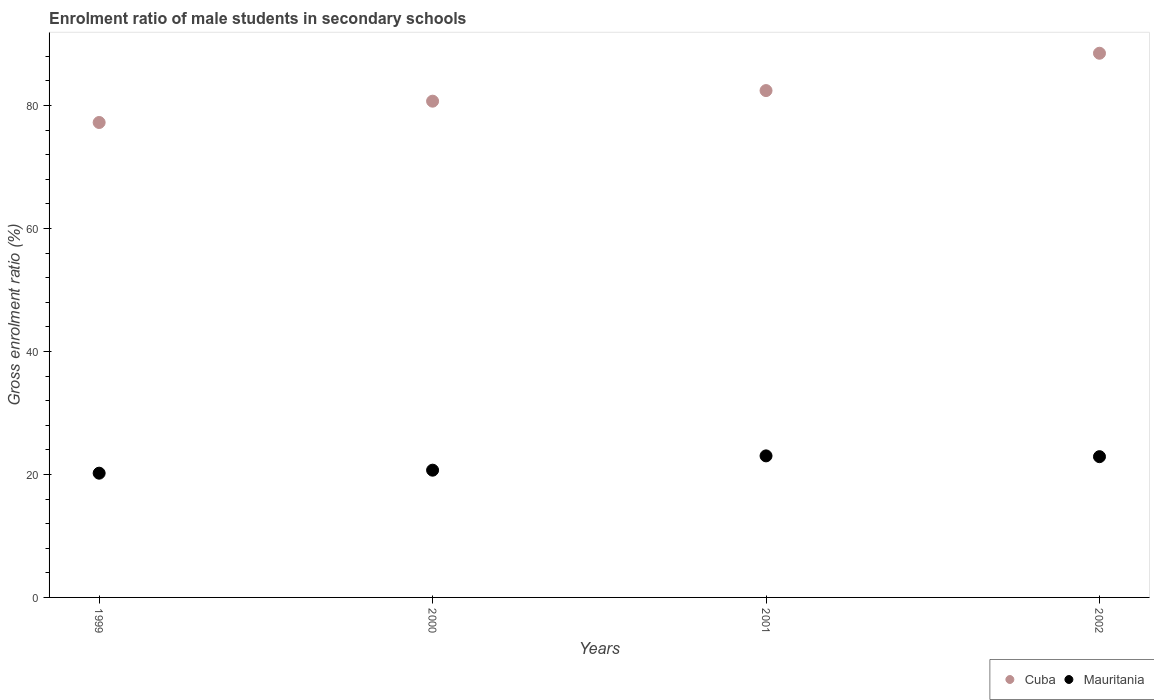What is the enrolment ratio of male students in secondary schools in Mauritania in 2000?
Provide a short and direct response. 20.69. Across all years, what is the maximum enrolment ratio of male students in secondary schools in Mauritania?
Give a very brief answer. 23.02. Across all years, what is the minimum enrolment ratio of male students in secondary schools in Mauritania?
Offer a terse response. 20.2. In which year was the enrolment ratio of male students in secondary schools in Mauritania maximum?
Your response must be concise. 2001. What is the total enrolment ratio of male students in secondary schools in Mauritania in the graph?
Your response must be concise. 86.8. What is the difference between the enrolment ratio of male students in secondary schools in Cuba in 2001 and that in 2002?
Provide a succinct answer. -6.07. What is the difference between the enrolment ratio of male students in secondary schools in Cuba in 2002 and the enrolment ratio of male students in secondary schools in Mauritania in 2001?
Provide a succinct answer. 65.47. What is the average enrolment ratio of male students in secondary schools in Cuba per year?
Provide a succinct answer. 82.21. In the year 2000, what is the difference between the enrolment ratio of male students in secondary schools in Cuba and enrolment ratio of male students in secondary schools in Mauritania?
Make the answer very short. 60. What is the ratio of the enrolment ratio of male students in secondary schools in Cuba in 1999 to that in 2000?
Make the answer very short. 0.96. Is the enrolment ratio of male students in secondary schools in Cuba in 1999 less than that in 2000?
Offer a terse response. Yes. Is the difference between the enrolment ratio of male students in secondary schools in Cuba in 1999 and 2002 greater than the difference between the enrolment ratio of male students in secondary schools in Mauritania in 1999 and 2002?
Provide a succinct answer. No. What is the difference between the highest and the second highest enrolment ratio of male students in secondary schools in Mauritania?
Ensure brevity in your answer.  0.13. What is the difference between the highest and the lowest enrolment ratio of male students in secondary schools in Mauritania?
Ensure brevity in your answer.  2.81. In how many years, is the enrolment ratio of male students in secondary schools in Cuba greater than the average enrolment ratio of male students in secondary schools in Cuba taken over all years?
Offer a very short reply. 2. Is the sum of the enrolment ratio of male students in secondary schools in Cuba in 2001 and 2002 greater than the maximum enrolment ratio of male students in secondary schools in Mauritania across all years?
Your response must be concise. Yes. Is the enrolment ratio of male students in secondary schools in Cuba strictly less than the enrolment ratio of male students in secondary schools in Mauritania over the years?
Give a very brief answer. No. How many years are there in the graph?
Offer a very short reply. 4. What is the difference between two consecutive major ticks on the Y-axis?
Your answer should be compact. 20. Are the values on the major ticks of Y-axis written in scientific E-notation?
Offer a terse response. No. Does the graph contain any zero values?
Keep it short and to the point. No. Where does the legend appear in the graph?
Give a very brief answer. Bottom right. How many legend labels are there?
Provide a short and direct response. 2. What is the title of the graph?
Offer a terse response. Enrolment ratio of male students in secondary schools. What is the label or title of the X-axis?
Your answer should be compact. Years. What is the label or title of the Y-axis?
Keep it short and to the point. Gross enrolment ratio (%). What is the Gross enrolment ratio (%) in Cuba in 1999?
Make the answer very short. 77.23. What is the Gross enrolment ratio (%) of Mauritania in 1999?
Ensure brevity in your answer.  20.2. What is the Gross enrolment ratio (%) of Cuba in 2000?
Make the answer very short. 80.69. What is the Gross enrolment ratio (%) of Mauritania in 2000?
Your answer should be very brief. 20.69. What is the Gross enrolment ratio (%) in Cuba in 2001?
Offer a very short reply. 82.42. What is the Gross enrolment ratio (%) of Mauritania in 2001?
Ensure brevity in your answer.  23.02. What is the Gross enrolment ratio (%) in Cuba in 2002?
Give a very brief answer. 88.49. What is the Gross enrolment ratio (%) of Mauritania in 2002?
Provide a short and direct response. 22.89. Across all years, what is the maximum Gross enrolment ratio (%) of Cuba?
Ensure brevity in your answer.  88.49. Across all years, what is the maximum Gross enrolment ratio (%) in Mauritania?
Offer a very short reply. 23.02. Across all years, what is the minimum Gross enrolment ratio (%) of Cuba?
Offer a very short reply. 77.23. Across all years, what is the minimum Gross enrolment ratio (%) in Mauritania?
Offer a terse response. 20.2. What is the total Gross enrolment ratio (%) of Cuba in the graph?
Offer a very short reply. 328.83. What is the total Gross enrolment ratio (%) in Mauritania in the graph?
Your response must be concise. 86.8. What is the difference between the Gross enrolment ratio (%) in Cuba in 1999 and that in 2000?
Make the answer very short. -3.47. What is the difference between the Gross enrolment ratio (%) in Mauritania in 1999 and that in 2000?
Give a very brief answer. -0.49. What is the difference between the Gross enrolment ratio (%) of Cuba in 1999 and that in 2001?
Offer a terse response. -5.19. What is the difference between the Gross enrolment ratio (%) of Mauritania in 1999 and that in 2001?
Keep it short and to the point. -2.81. What is the difference between the Gross enrolment ratio (%) of Cuba in 1999 and that in 2002?
Offer a very short reply. -11.26. What is the difference between the Gross enrolment ratio (%) of Mauritania in 1999 and that in 2002?
Your response must be concise. -2.69. What is the difference between the Gross enrolment ratio (%) in Cuba in 2000 and that in 2001?
Your answer should be compact. -1.72. What is the difference between the Gross enrolment ratio (%) of Mauritania in 2000 and that in 2001?
Provide a short and direct response. -2.32. What is the difference between the Gross enrolment ratio (%) of Cuba in 2000 and that in 2002?
Offer a terse response. -7.79. What is the difference between the Gross enrolment ratio (%) of Mauritania in 2000 and that in 2002?
Offer a terse response. -2.2. What is the difference between the Gross enrolment ratio (%) of Cuba in 2001 and that in 2002?
Provide a short and direct response. -6.07. What is the difference between the Gross enrolment ratio (%) of Mauritania in 2001 and that in 2002?
Ensure brevity in your answer.  0.13. What is the difference between the Gross enrolment ratio (%) in Cuba in 1999 and the Gross enrolment ratio (%) in Mauritania in 2000?
Give a very brief answer. 56.54. What is the difference between the Gross enrolment ratio (%) of Cuba in 1999 and the Gross enrolment ratio (%) of Mauritania in 2001?
Your response must be concise. 54.21. What is the difference between the Gross enrolment ratio (%) of Cuba in 1999 and the Gross enrolment ratio (%) of Mauritania in 2002?
Your answer should be compact. 54.34. What is the difference between the Gross enrolment ratio (%) of Cuba in 2000 and the Gross enrolment ratio (%) of Mauritania in 2001?
Your answer should be very brief. 57.68. What is the difference between the Gross enrolment ratio (%) in Cuba in 2000 and the Gross enrolment ratio (%) in Mauritania in 2002?
Provide a succinct answer. 57.8. What is the difference between the Gross enrolment ratio (%) of Cuba in 2001 and the Gross enrolment ratio (%) of Mauritania in 2002?
Provide a succinct answer. 59.53. What is the average Gross enrolment ratio (%) of Cuba per year?
Make the answer very short. 82.21. What is the average Gross enrolment ratio (%) of Mauritania per year?
Ensure brevity in your answer.  21.7. In the year 1999, what is the difference between the Gross enrolment ratio (%) in Cuba and Gross enrolment ratio (%) in Mauritania?
Offer a terse response. 57.03. In the year 2000, what is the difference between the Gross enrolment ratio (%) of Cuba and Gross enrolment ratio (%) of Mauritania?
Provide a short and direct response. 60. In the year 2001, what is the difference between the Gross enrolment ratio (%) of Cuba and Gross enrolment ratio (%) of Mauritania?
Your answer should be compact. 59.4. In the year 2002, what is the difference between the Gross enrolment ratio (%) in Cuba and Gross enrolment ratio (%) in Mauritania?
Provide a short and direct response. 65.6. What is the ratio of the Gross enrolment ratio (%) of Cuba in 1999 to that in 2000?
Offer a terse response. 0.96. What is the ratio of the Gross enrolment ratio (%) of Mauritania in 1999 to that in 2000?
Offer a very short reply. 0.98. What is the ratio of the Gross enrolment ratio (%) of Cuba in 1999 to that in 2001?
Your answer should be compact. 0.94. What is the ratio of the Gross enrolment ratio (%) in Mauritania in 1999 to that in 2001?
Keep it short and to the point. 0.88. What is the ratio of the Gross enrolment ratio (%) of Cuba in 1999 to that in 2002?
Ensure brevity in your answer.  0.87. What is the ratio of the Gross enrolment ratio (%) in Mauritania in 1999 to that in 2002?
Offer a very short reply. 0.88. What is the ratio of the Gross enrolment ratio (%) of Cuba in 2000 to that in 2001?
Offer a terse response. 0.98. What is the ratio of the Gross enrolment ratio (%) in Mauritania in 2000 to that in 2001?
Make the answer very short. 0.9. What is the ratio of the Gross enrolment ratio (%) of Cuba in 2000 to that in 2002?
Ensure brevity in your answer.  0.91. What is the ratio of the Gross enrolment ratio (%) in Mauritania in 2000 to that in 2002?
Offer a terse response. 0.9. What is the ratio of the Gross enrolment ratio (%) of Cuba in 2001 to that in 2002?
Offer a terse response. 0.93. What is the ratio of the Gross enrolment ratio (%) of Mauritania in 2001 to that in 2002?
Provide a short and direct response. 1.01. What is the difference between the highest and the second highest Gross enrolment ratio (%) in Cuba?
Your answer should be compact. 6.07. What is the difference between the highest and the second highest Gross enrolment ratio (%) of Mauritania?
Give a very brief answer. 0.13. What is the difference between the highest and the lowest Gross enrolment ratio (%) of Cuba?
Ensure brevity in your answer.  11.26. What is the difference between the highest and the lowest Gross enrolment ratio (%) in Mauritania?
Keep it short and to the point. 2.81. 